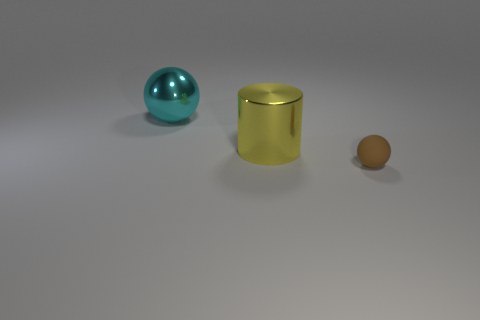What is the color of the cylinder?
Make the answer very short. Yellow. What is the thing that is both to the right of the big cyan ball and behind the tiny brown matte ball made of?
Offer a very short reply. Metal. There is a large metal thing that is in front of the big ball behind the large cylinder; are there any large metal cylinders that are on the left side of it?
Provide a succinct answer. No. There is a tiny ball; are there any small things in front of it?
Make the answer very short. No. What number of other objects are there of the same shape as the small brown matte object?
Ensure brevity in your answer.  1. What is the color of the other thing that is the same size as the yellow shiny thing?
Offer a terse response. Cyan. Is the number of tiny brown objects behind the cyan shiny thing less than the number of yellow cylinders to the right of the metal cylinder?
Your response must be concise. No. What number of cyan objects are to the right of the ball to the left of the sphere that is in front of the big yellow metallic cylinder?
Provide a short and direct response. 0. What is the size of the other object that is the same shape as the tiny matte thing?
Your answer should be very brief. Large. Is there anything else that has the same size as the yellow metallic cylinder?
Give a very brief answer. Yes. 